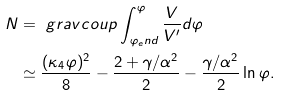Convert formula to latex. <formula><loc_0><loc_0><loc_500><loc_500>N & = \ g r a v c o u p \int _ { \varphi _ { e } n d } ^ { \varphi } \frac { V } { V ^ { \prime } } d \varphi \\ & \simeq \frac { ( \kappa _ { 4 } \varphi ) ^ { 2 } } { 8 } - \frac { 2 + \gamma / \alpha ^ { 2 } } { 2 } - \frac { \gamma / \alpha ^ { 2 } } { 2 } \ln \varphi .</formula> 